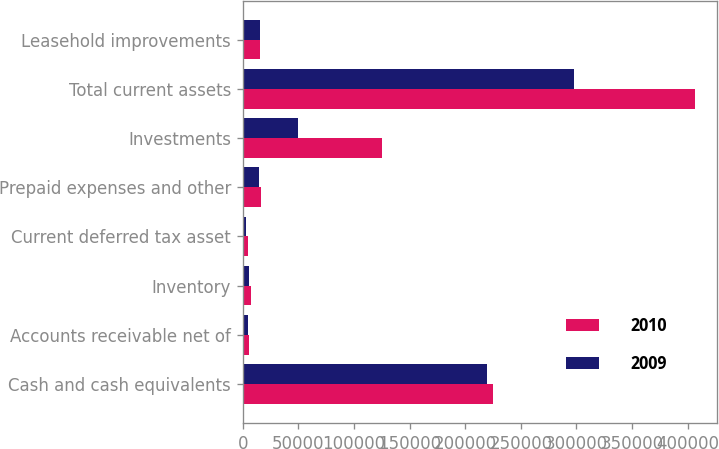<chart> <loc_0><loc_0><loc_500><loc_500><stacked_bar_chart><ecel><fcel>Cash and cash equivalents<fcel>Accounts receivable net of<fcel>Inventory<fcel>Current deferred tax asset<fcel>Prepaid expenses and other<fcel>Investments<fcel>Total current assets<fcel>Leasehold improvements<nl><fcel>2010<fcel>224838<fcel>5658<fcel>7098<fcel>4317<fcel>16016<fcel>124766<fcel>406221<fcel>15196.5<nl><fcel>2009<fcel>219566<fcel>4763<fcel>5614<fcel>3134<fcel>14377<fcel>50000<fcel>297454<fcel>15196.5<nl></chart> 